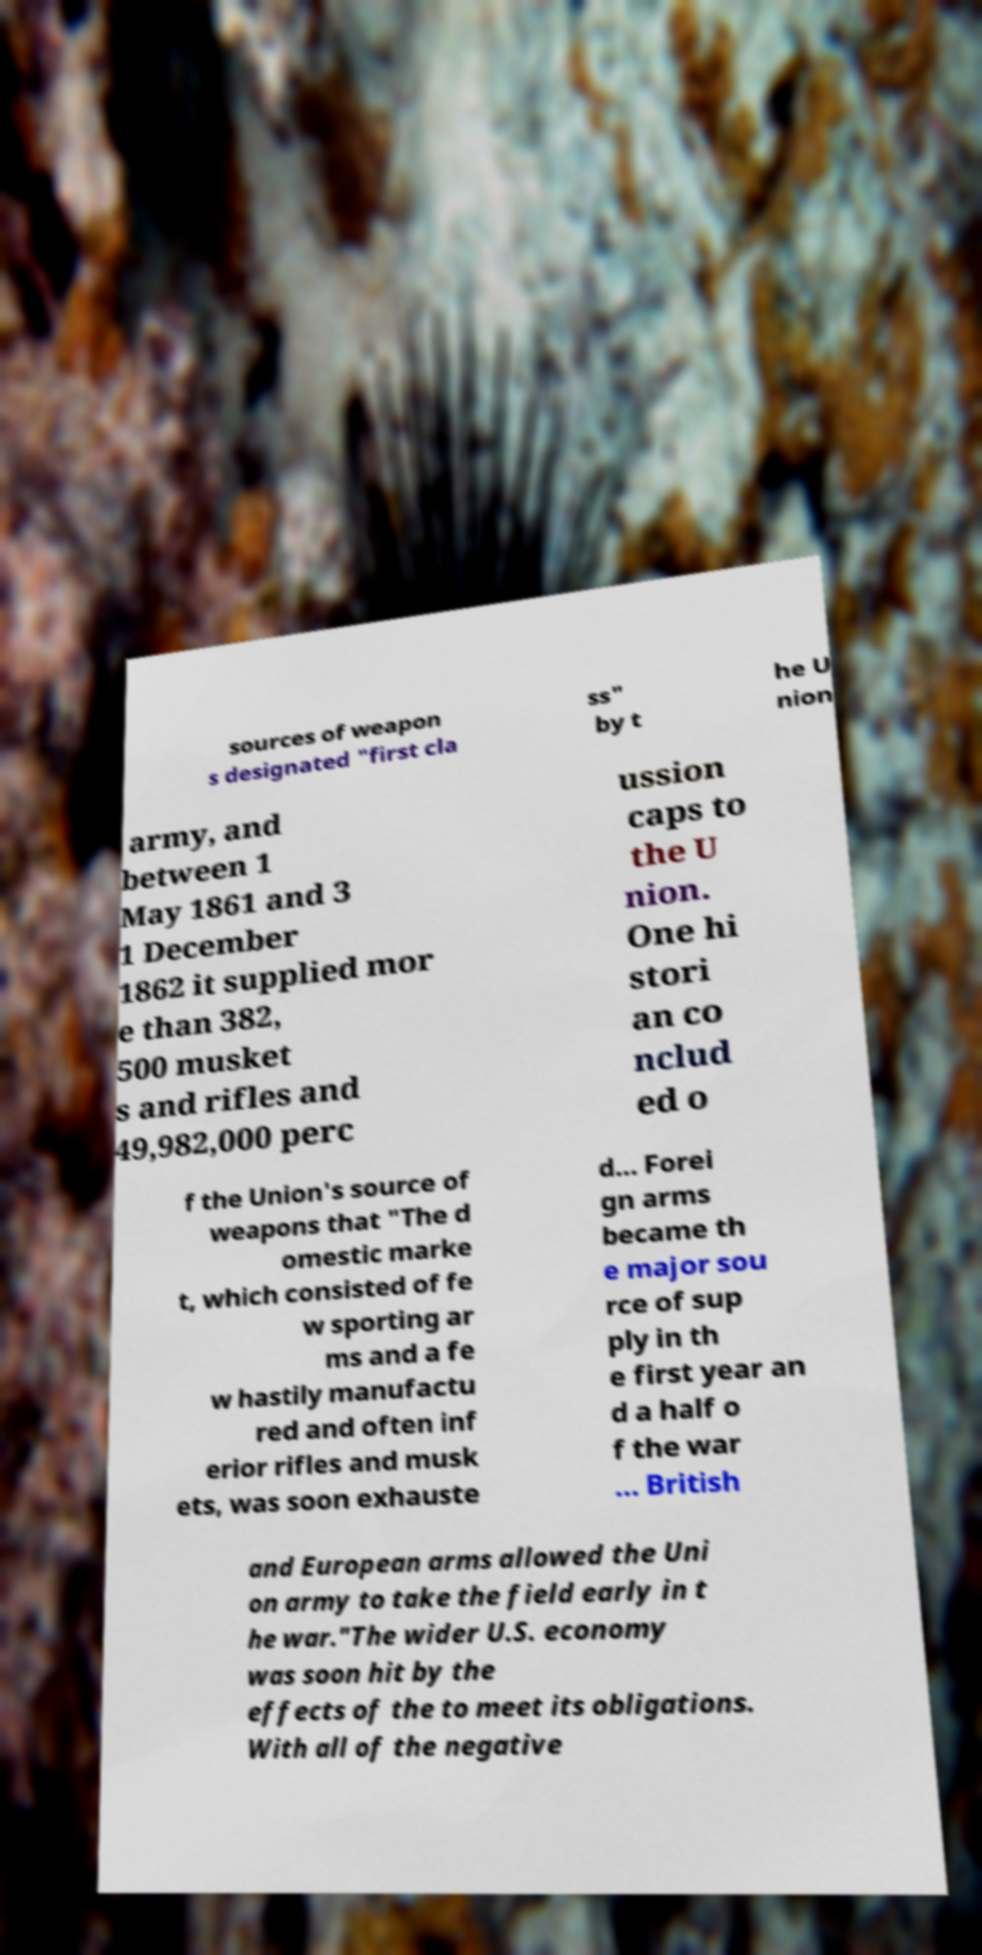Please read and relay the text visible in this image. What does it say? sources of weapon s designated "first cla ss" by t he U nion army, and between 1 May 1861 and 3 1 December 1862 it supplied mor e than 382, 500 musket s and rifles and 49,982,000 perc ussion caps to the U nion. One hi stori an co nclud ed o f the Union's source of weapons that "The d omestic marke t, which consisted of fe w sporting ar ms and a fe w hastily manufactu red and often inf erior rifles and musk ets, was soon exhauste d… Forei gn arms became th e major sou rce of sup ply in th e first year an d a half o f the war … British and European arms allowed the Uni on army to take the field early in t he war."The wider U.S. economy was soon hit by the effects of the to meet its obligations. With all of the negative 